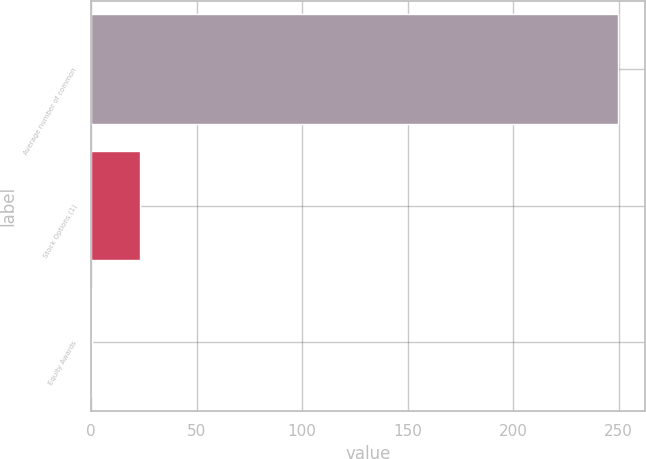Convert chart to OTSL. <chart><loc_0><loc_0><loc_500><loc_500><bar_chart><fcel>Average number of common<fcel>Stock Options (1)<fcel>Equity Awards<nl><fcel>249.89<fcel>23.29<fcel>0.2<nl></chart> 